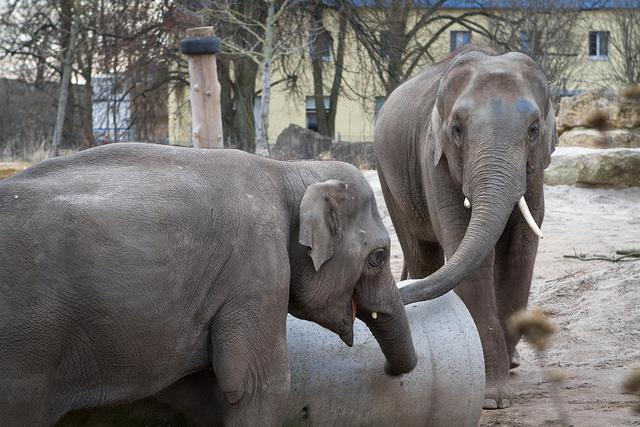Six elephants are pictured?
Answer briefly. No. Do the elephants look friendly?
Be succinct. Yes. Where are the elephants?
Concise answer only. Zoo. How many elephants are there?
Quick response, please. 2. Is the elephant dirty?
Give a very brief answer. No. Are the elephants moving?
Quick response, please. Yes. Are they on sand?
Quick response, please. Yes. 